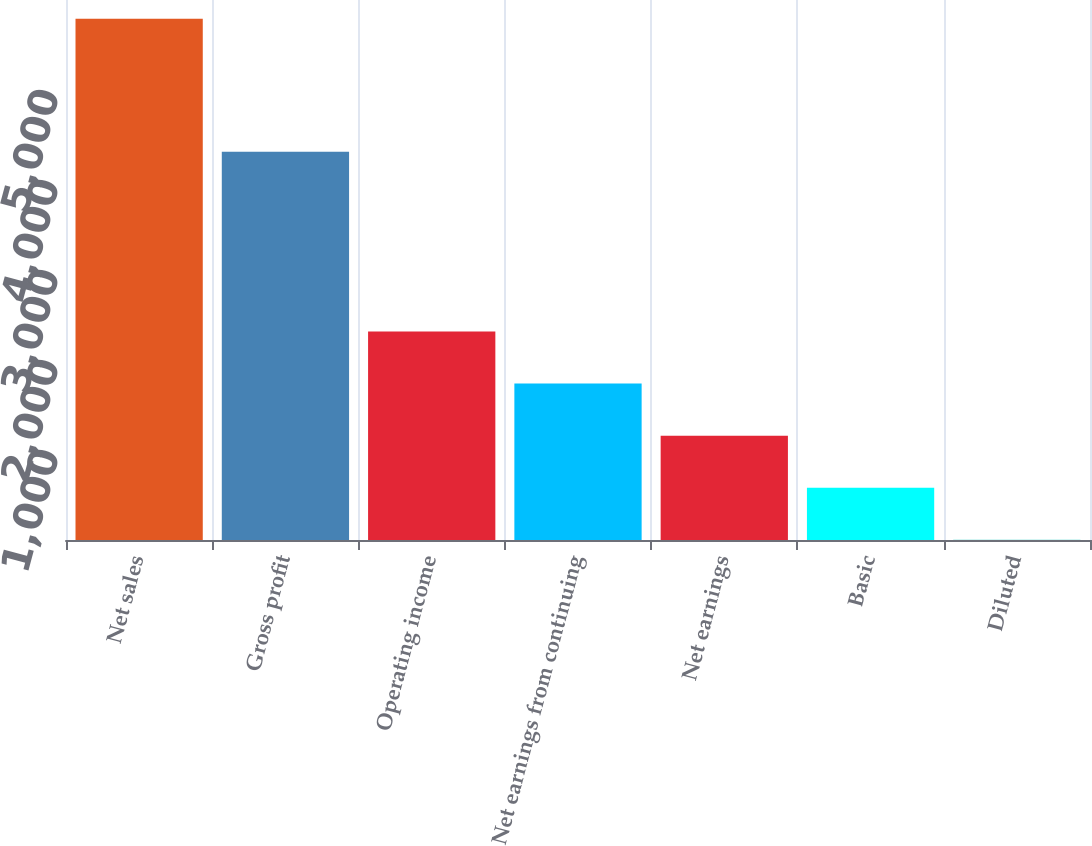Convert chart to OTSL. <chart><loc_0><loc_0><loc_500><loc_500><bar_chart><fcel>Net sales<fcel>Gross profit<fcel>Operating income<fcel>Net earnings from continuing<fcel>Net earnings<fcel>Basic<fcel>Diluted<nl><fcel>5790.4<fcel>4314.1<fcel>2317.14<fcel>1738.26<fcel>1159.38<fcel>580.5<fcel>1.62<nl></chart> 